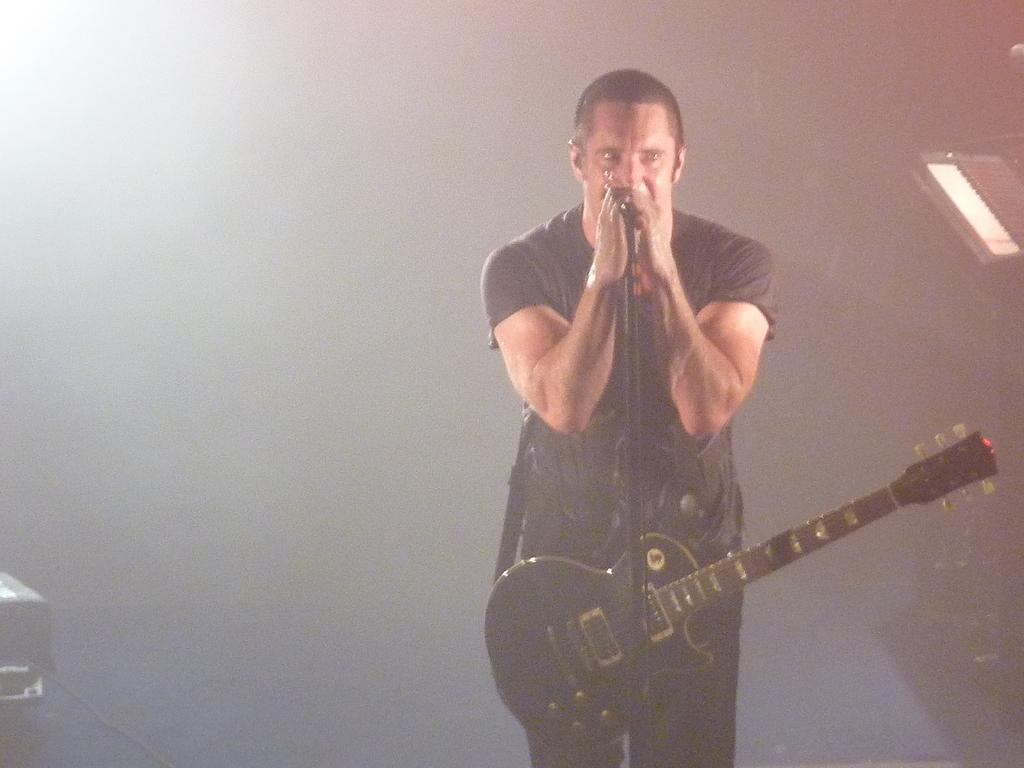What is the main subject of the image? The main subject of the image is a man. What is the man wearing? The man is wearing a black t-shirt. What is the man holding in his hand? The man is holding a microphone in his hand. What instrument is the man wearing? The man is wearing a guitar. What objects can be seen in the corners of the image? There is a black box with a wire in the left corner of the image, and there is a piano in the right top corner of the image. What type of store can be seen in the background of the image? There is no store visible in the image; it features a man holding a microphone and wearing a guitar. Can you hear the man's voice in the image? The image is a still photograph, so it does not capture sound. Therefore, we cannot hear the man's voice in the image. 